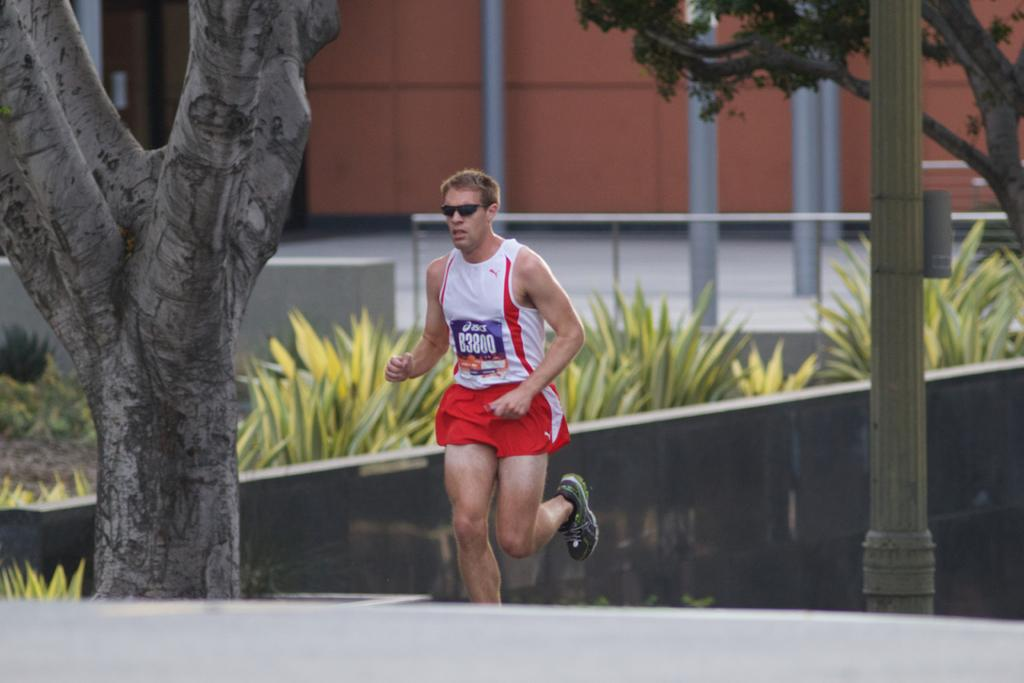What is the man in the image doing? The man is jogging in the image. Where is the man jogging? The man is on a path. What can be seen beside the path? There are trees beside the path. What is visible in the background of the image? There is a wall, plants, a railing, and a building with walls in the background. What else can be seen in the background? There are poles visible in the background. What type of bells can be heard ringing in the image? There are no bells present in the image, and therefore no sounds can be heard. 